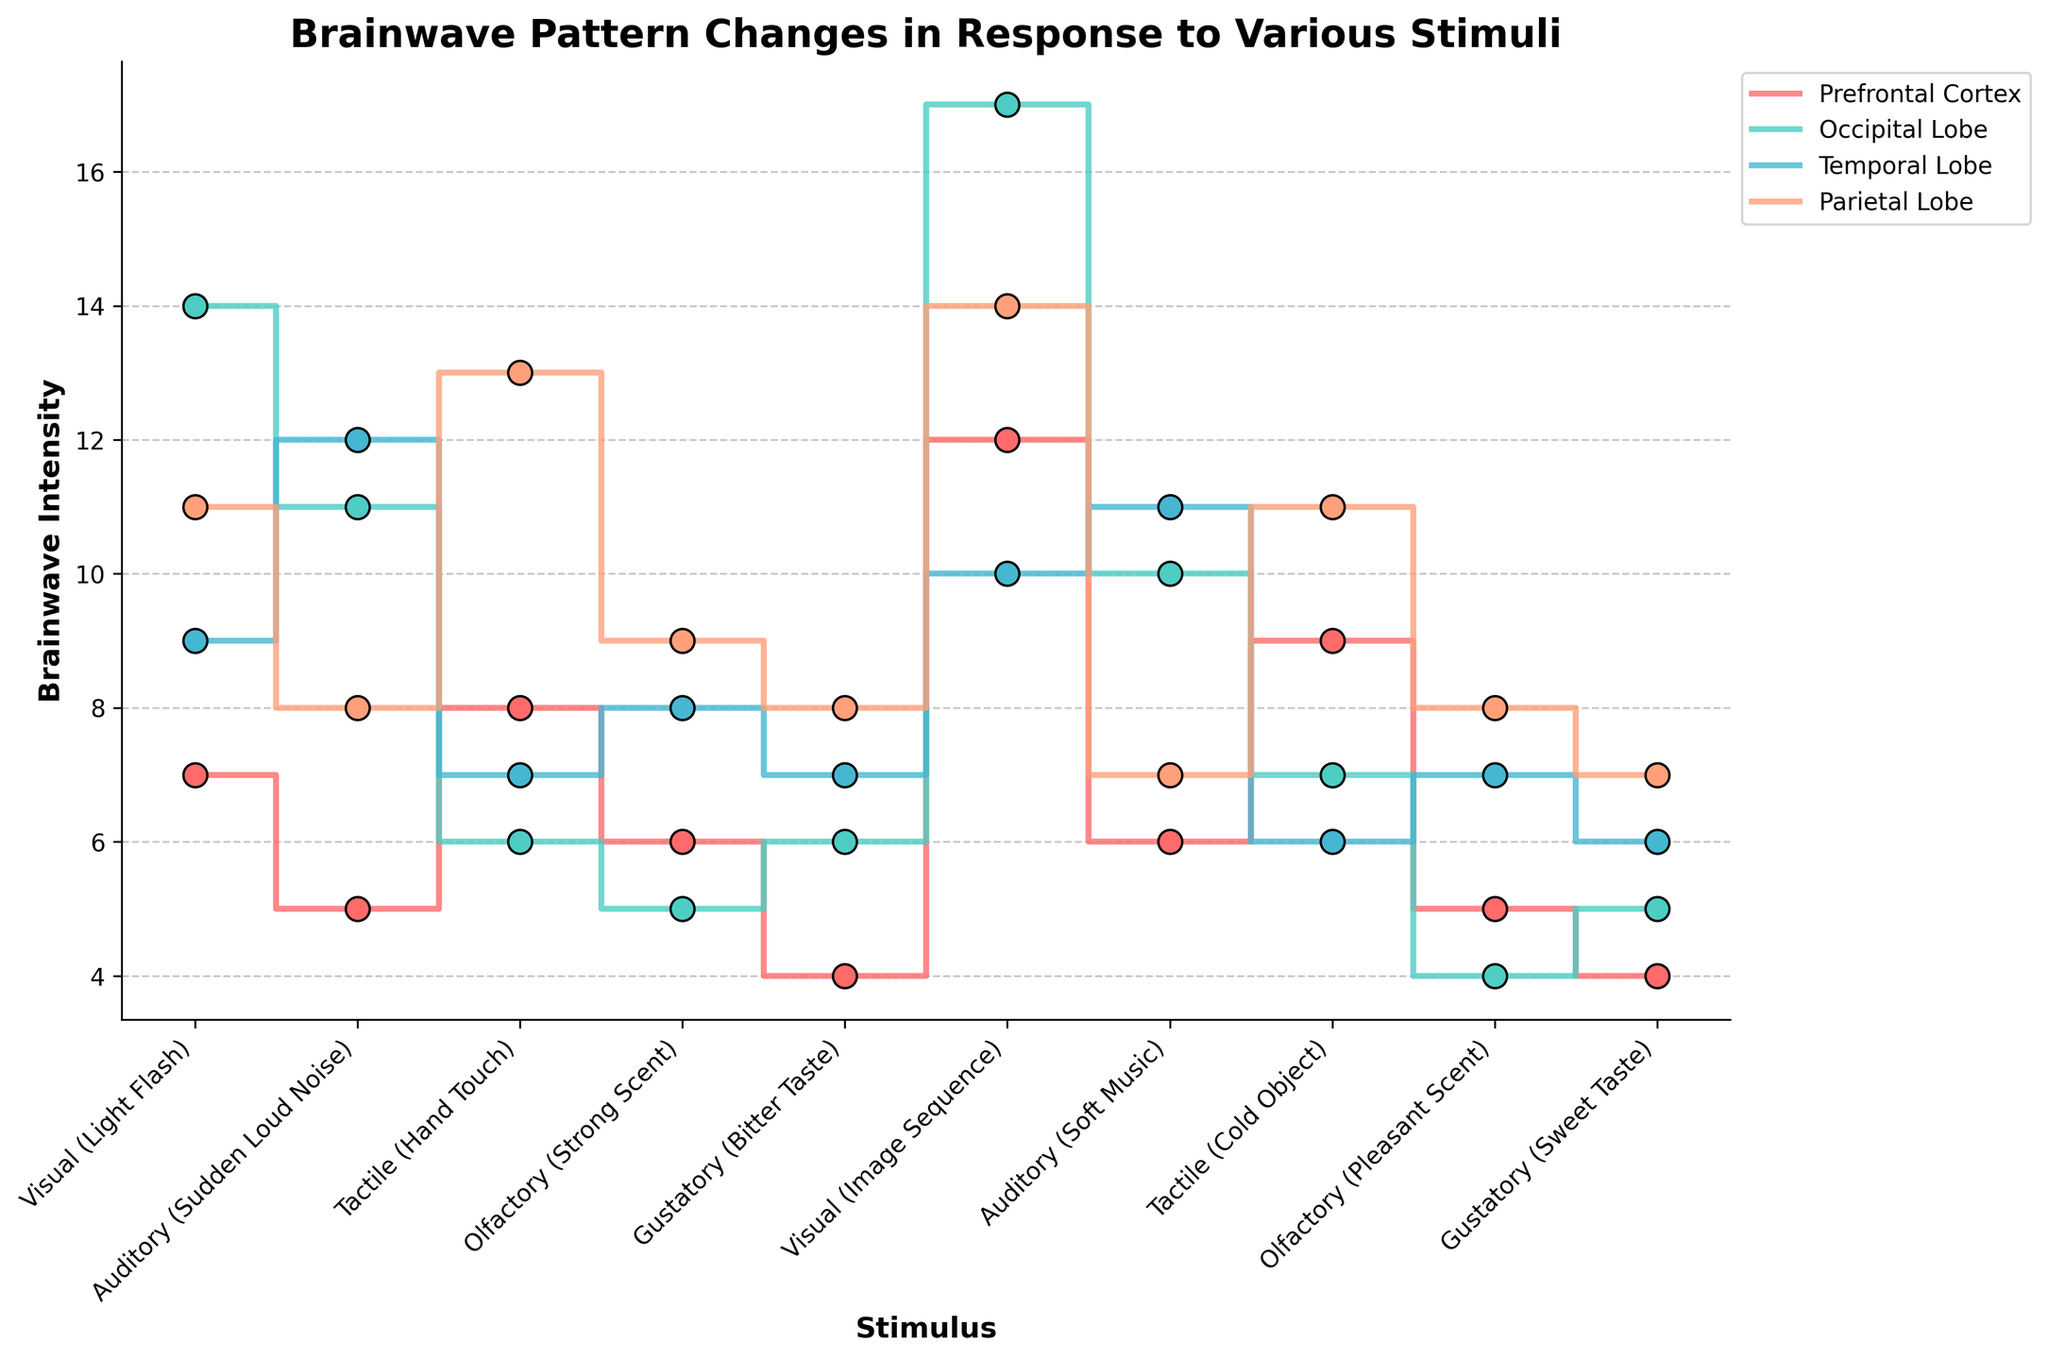How many types of stimuli are represented in the figure? Count the number of different stimuli listed on the x-axis in the plot.
Answer: 10 Which brain region shows the highest intensity for the "Visual (Light Flash)" stimulus? Find the data points for the "Visual (Light Flash)" stimulus and identify the highest value among the brain regions.
Answer: Occipital Lobe For which brain region does the "Auditory (Sudden Loud Noise)" stimulus show the highest brainwave intensity? Look at the data points for each brain region under the "Auditory (Sudden Loud Noise)" stimulus and identify the highest one.
Answer: Temporal Lobe What is the average brainwave intensity for the "Gustatory (Bitter Taste)" stimulus? Add the values of brainwave intensities across all brain regions for the stimulus and divide by the number of regions (4). (4 + 6 + 7 + 8) / 4 = 25 / 4 = 6.25
Answer: 6.25 Which stimuli resulted in similar brainwave intensities in the Prefrontal Cortex? Compare the values for the Prefrontal Cortex region across stimuli and identify stimuli with the same or very similar values. (Gustatory (Bitter Taste): 4, Gustatory (Sweet Taste): 4)
Answer: Gustatory (Bitter Taste) and Gustatory (Sweet Taste) What is the difference in brainwave intensity between "Visual (Image Sequence)" and "Auditory (Soft Music)" in the Occipital Lobe? Subtract the value for "Auditory (Soft Music)" from the value for "Visual (Image Sequence)" in the Occipital Lobe. (17 - 10)
Answer: 7 Which brain region shows the most variability in brainwave intensities across all stimuli? Examine the range of brainwave intensities for each brain region and find the one with the largest range. The Temporal Lobe ranges from 6 to 12, which is the widest.
Answer: Temporal Lobe How many stimuli show a brainwave intensity of exactly 7 in the Temporal Lobe? Identify and count the stimuli that have a brainwave intensity of 7 in the Temporal Lobe.
Answer: 2 Which stimulus results in the lowest brainwave intensity in the Prefrontal Cortex? Identify the stimulus with the lowest value in the Prefrontal Cortex region.
Answer: Gustatory (Sweet Taste) What is the total brainwave intensity for "Tactile (Cold Object)" across all brain regions? Add the values of brainwave intensities for each brain region under the "Tactile (Cold Object)" stimulus. (9 + 7 + 6 + 11) = 33
Answer: 33 